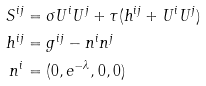<formula> <loc_0><loc_0><loc_500><loc_500>S ^ { i j } & = \sigma U ^ { i } U ^ { j } + \tau ( h ^ { i j } + U ^ { i } U ^ { j } ) \\ h ^ { i j } & = g ^ { i j } - n ^ { i } n ^ { j } \\ n ^ { i } & = ( 0 , e ^ { - \lambda } , 0 , 0 )</formula> 